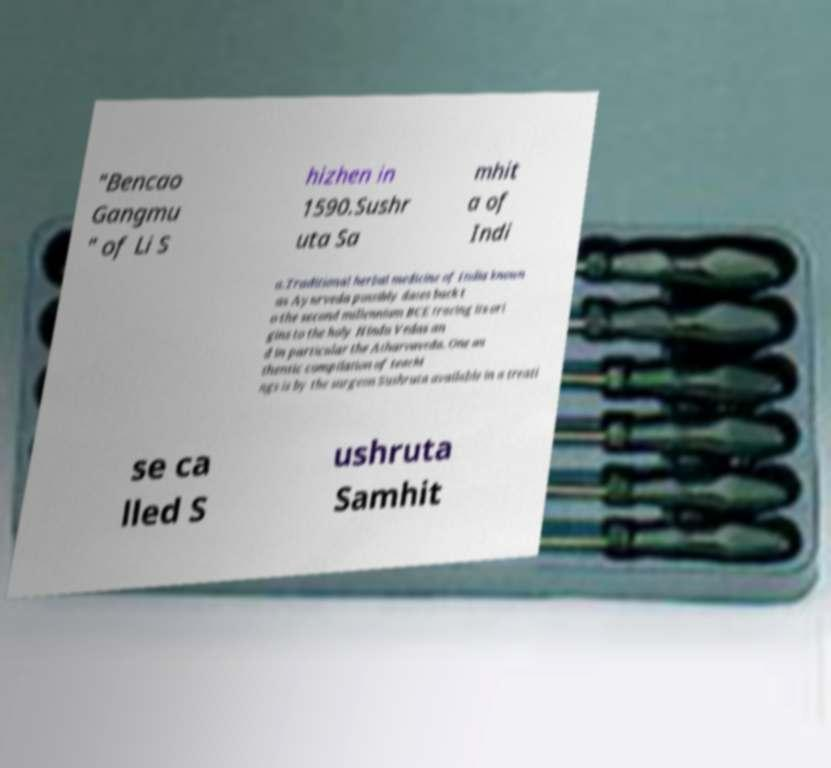There's text embedded in this image that I need extracted. Can you transcribe it verbatim? "Bencao Gangmu " of Li S hizhen in 1590.Sushr uta Sa mhit a of Indi a.Traditional herbal medicine of India known as Ayurveda possibly dates back t o the second millennium BCE tracing its ori gins to the holy Hindu Vedas an d in particular the Atharvaveda. One au thentic compilation of teachi ngs is by the surgeon Sushruta available in a treati se ca lled S ushruta Samhit 